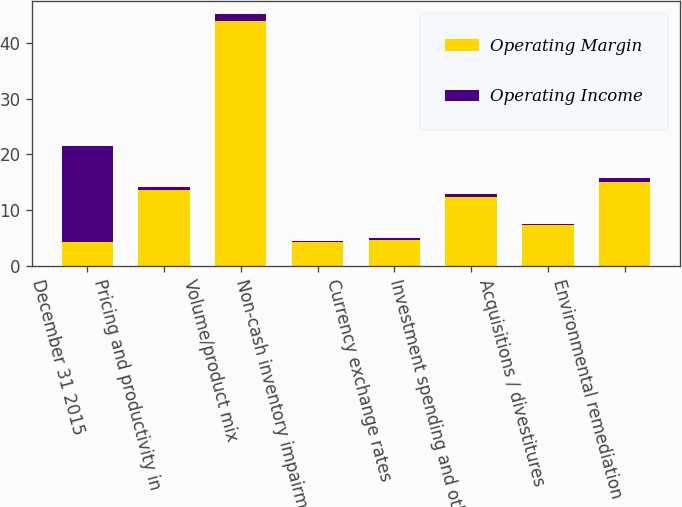<chart> <loc_0><loc_0><loc_500><loc_500><stacked_bar_chart><ecel><fcel>December 31 2015<fcel>Pricing and productivity in<fcel>Volume/product mix<fcel>Non-cash inventory impairment<fcel>Currency exchange rates<fcel>Investment spending and other<fcel>Acquisitions / divestitures<fcel>Environmental remediation<nl><fcel>Operating Margin<fcel>4.2<fcel>13.6<fcel>44<fcel>4.2<fcel>4.6<fcel>12.3<fcel>7.3<fcel>15<nl><fcel>Operating Income<fcel>17.3<fcel>0.5<fcel>1.2<fcel>0.2<fcel>0.3<fcel>0.6<fcel>0.2<fcel>0.7<nl></chart> 